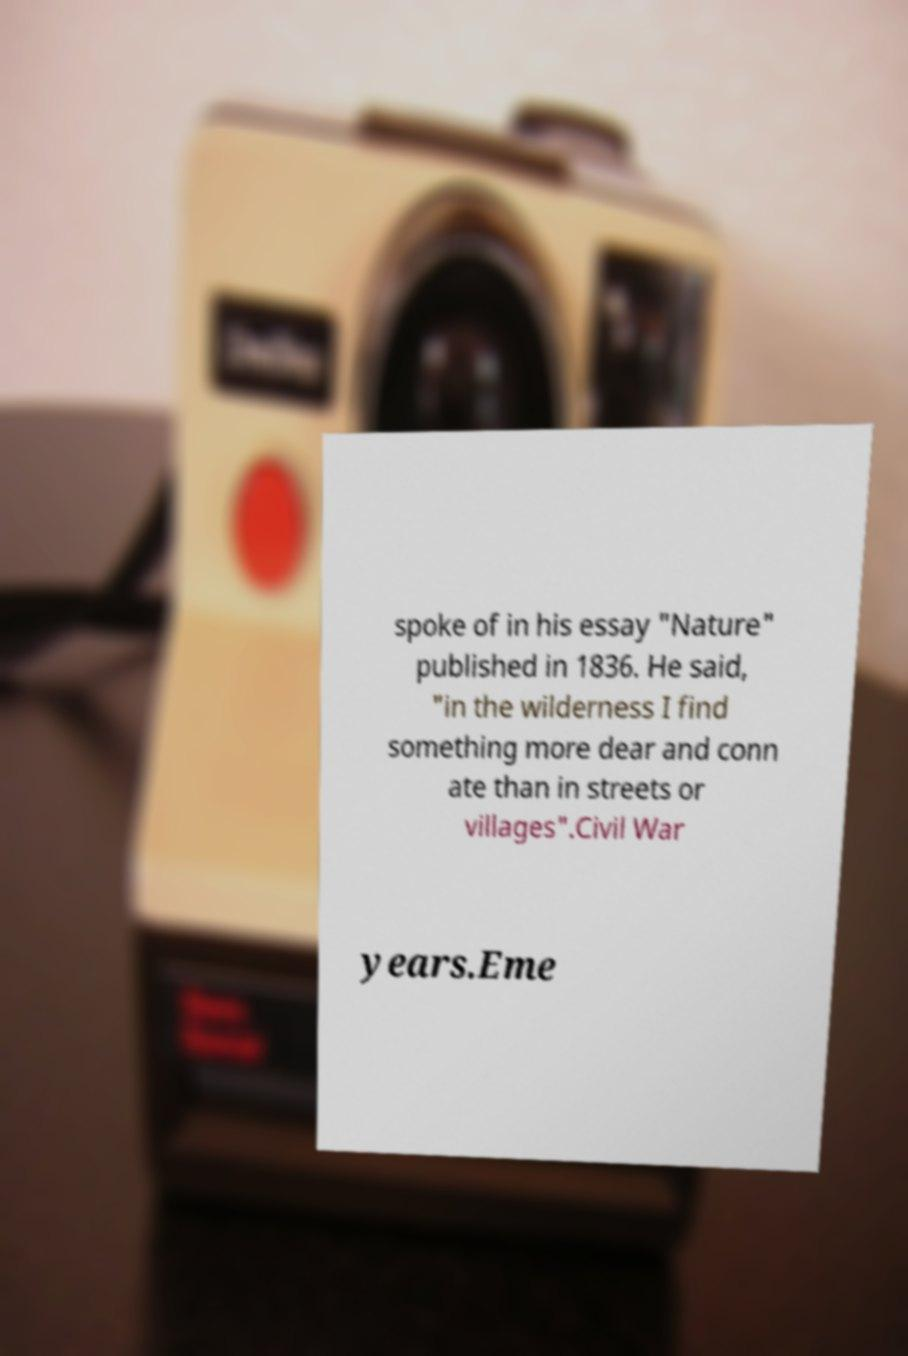Please identify and transcribe the text found in this image. spoke of in his essay "Nature" published in 1836. He said, "in the wilderness I find something more dear and conn ate than in streets or villages".Civil War years.Eme 